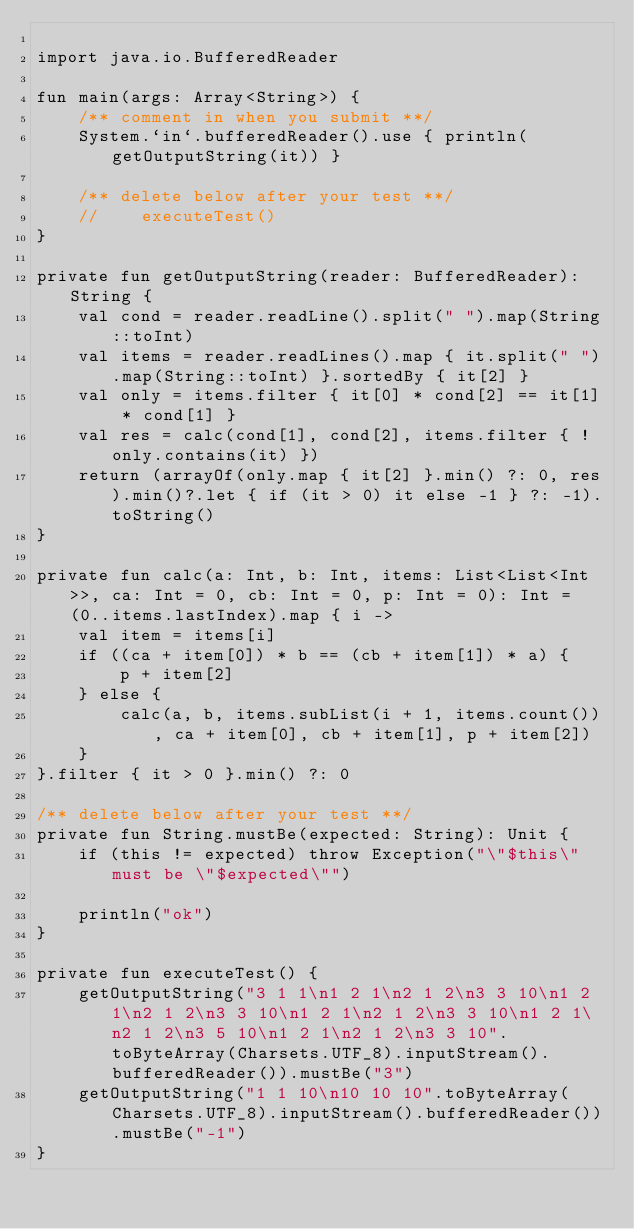Convert code to text. <code><loc_0><loc_0><loc_500><loc_500><_Kotlin_>
import java.io.BufferedReader

fun main(args: Array<String>) {
    /** comment in when you submit **/
    System.`in`.bufferedReader().use { println(getOutputString(it)) }

    /** delete below after your test **/
    //    executeTest()
}

private fun getOutputString(reader: BufferedReader): String {
    val cond = reader.readLine().split(" ").map(String::toInt)
    val items = reader.readLines().map { it.split(" ").map(String::toInt) }.sortedBy { it[2] }
    val only = items.filter { it[0] * cond[2] == it[1] * cond[1] }
    val res = calc(cond[1], cond[2], items.filter { !only.contains(it) })
    return (arrayOf(only.map { it[2] }.min() ?: 0, res).min()?.let { if (it > 0) it else -1 } ?: -1).toString()
}

private fun calc(a: Int, b: Int, items: List<List<Int>>, ca: Int = 0, cb: Int = 0, p: Int = 0): Int = (0..items.lastIndex).map { i ->
    val item = items[i]
    if ((ca + item[0]) * b == (cb + item[1]) * a) {
        p + item[2]
    } else {
        calc(a, b, items.subList(i + 1, items.count()), ca + item[0], cb + item[1], p + item[2])
    }
}.filter { it > 0 }.min() ?: 0

/** delete below after your test **/
private fun String.mustBe(expected: String): Unit {
    if (this != expected) throw Exception("\"$this\" must be \"$expected\"")

    println("ok")
}

private fun executeTest() {
    getOutputString("3 1 1\n1 2 1\n2 1 2\n3 3 10\n1 2 1\n2 1 2\n3 3 10\n1 2 1\n2 1 2\n3 3 10\n1 2 1\n2 1 2\n3 5 10\n1 2 1\n2 1 2\n3 3 10".toByteArray(Charsets.UTF_8).inputStream().bufferedReader()).mustBe("3")
    getOutputString("1 1 10\n10 10 10".toByteArray(Charsets.UTF_8).inputStream().bufferedReader()).mustBe("-1")
}
</code> 